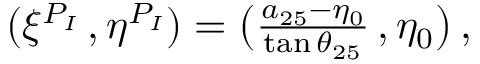<formula> <loc_0><loc_0><loc_500><loc_500>\begin{array} { r } { ( \xi ^ { P _ { I } } \, , \eta ^ { P _ { I } } ) = \left ( \frac { a _ { 2 5 } - \eta _ { 0 } } { \tan { \theta _ { 2 5 } } } \, , \eta _ { 0 } \right ) \, , } \end{array}</formula> 